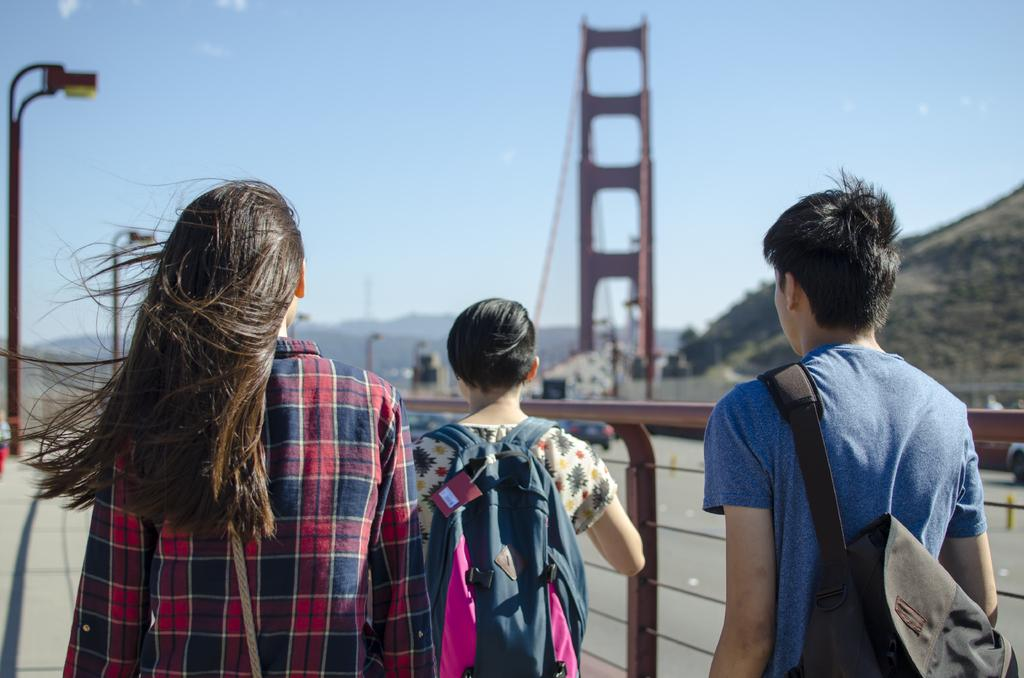What are the persons in the image doing? The persons in the image are walking on the road. What can be seen in the background of the image? In the background of the image, there is a car, a bridge, poles, a hill, and the sky. What is the condition of the sky in the image? The sky is visible in the background of the image, and there are clouds present. What type of coach is teaching the persons in the image? There is no coach or teaching activity present in the image; the persons are simply walking on the road. What fictional characters are interacting with the persons in the image? There are no fictional characters present in the image; the persons are walking on the road in a real-world setting. 